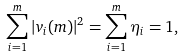<formula> <loc_0><loc_0><loc_500><loc_500>\sum _ { i = 1 } ^ { m } | v _ { i } ( m ) | ^ { 2 } = \sum _ { i = 1 } ^ { m } \eta _ { i } = 1 ,</formula> 